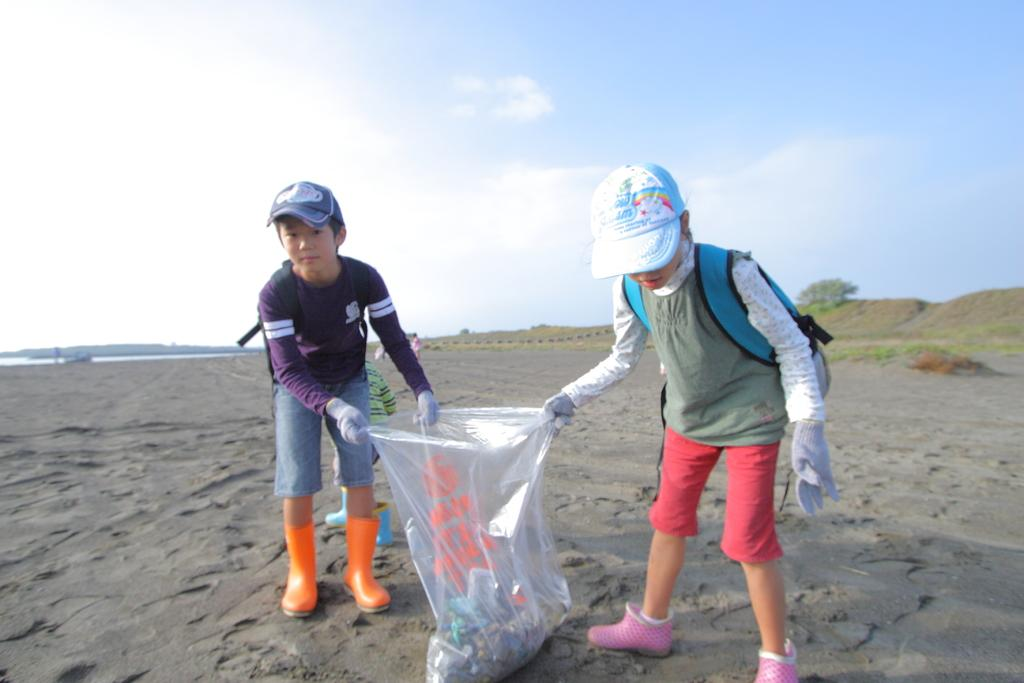How many kids are in the image? There are two kids in the image. What are the kids wearing on their heads? The kids are wearing caps. What are the kids holding in the image? The kids are holding a bag. What can be seen in the background of the image? There are people, trees, and water visible in the background of the image. What type of rhythm can be heard coming from the airplane in the image? There is no airplane present in the image, so it's not possible to determine what, if any, rhythm might be heard. 